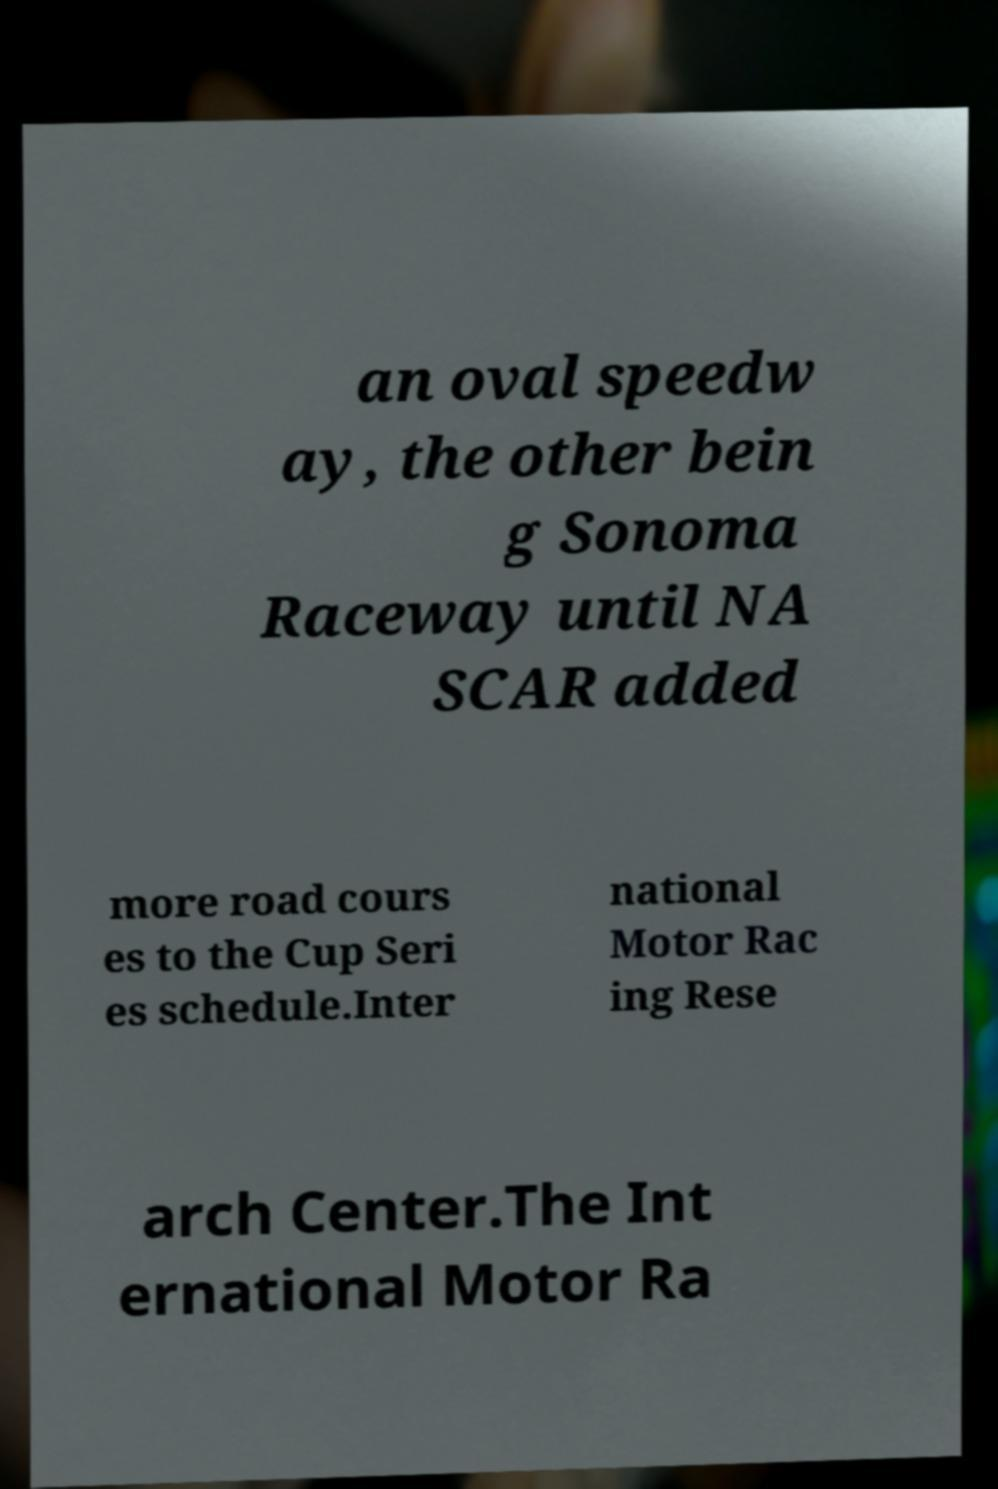Could you assist in decoding the text presented in this image and type it out clearly? an oval speedw ay, the other bein g Sonoma Raceway until NA SCAR added more road cours es to the Cup Seri es schedule.Inter national Motor Rac ing Rese arch Center.The Int ernational Motor Ra 